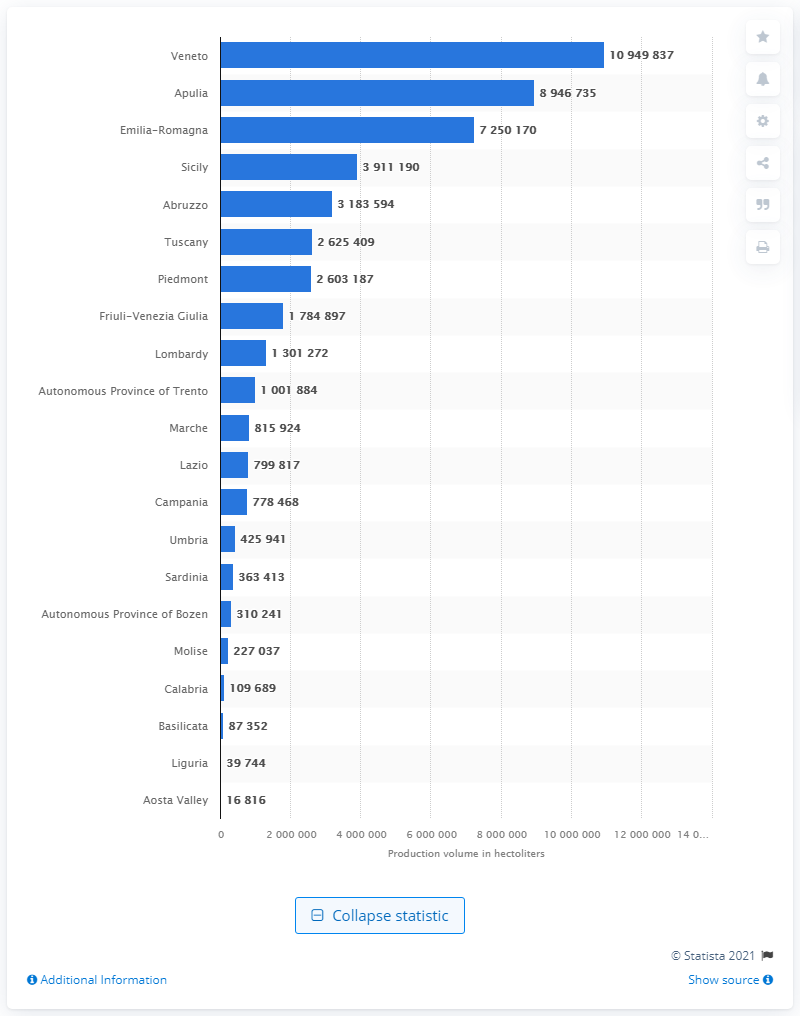Highlight a few significant elements in this photo. The Veneto region was the leading Italian region in terms of the volume of wine produced in 2021. 